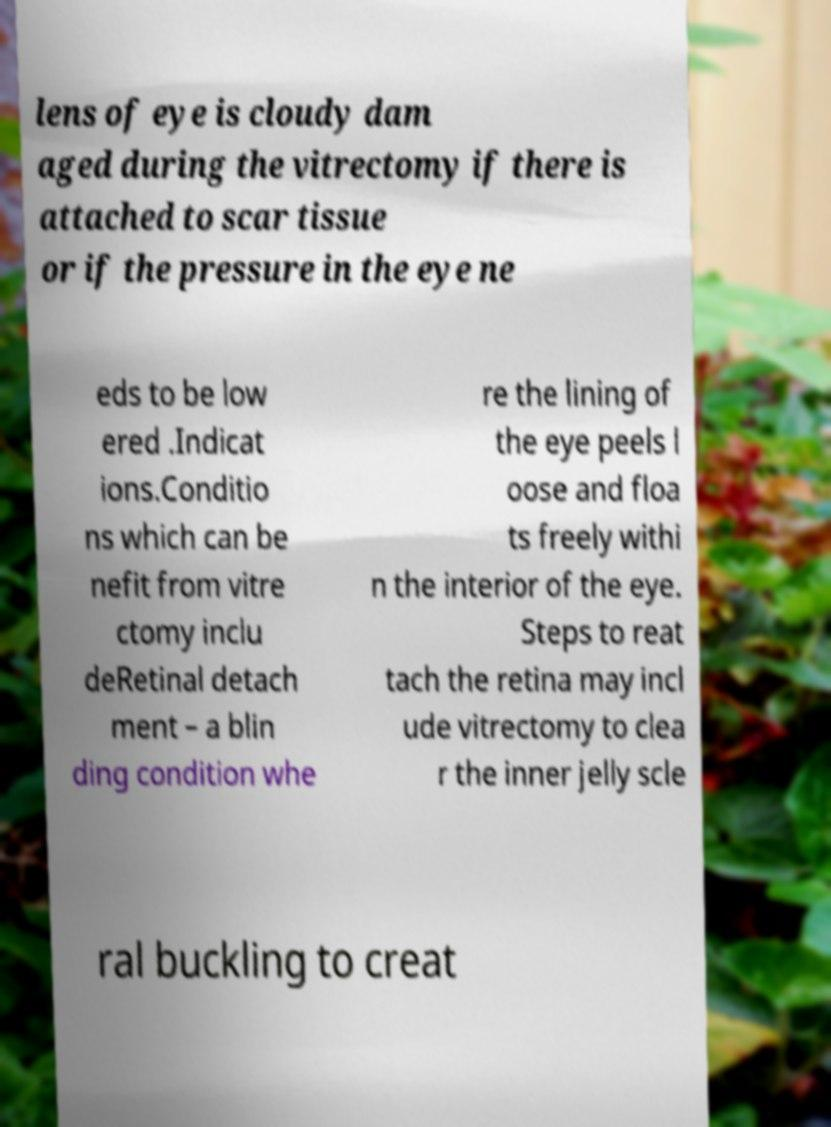Could you extract and type out the text from this image? lens of eye is cloudy dam aged during the vitrectomy if there is attached to scar tissue or if the pressure in the eye ne eds to be low ered .Indicat ions.Conditio ns which can be nefit from vitre ctomy inclu deRetinal detach ment – a blin ding condition whe re the lining of the eye peels l oose and floa ts freely withi n the interior of the eye. Steps to reat tach the retina may incl ude vitrectomy to clea r the inner jelly scle ral buckling to creat 